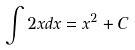<formula> <loc_0><loc_0><loc_500><loc_500>\int 2 x d x = x ^ { 2 } + C</formula> 